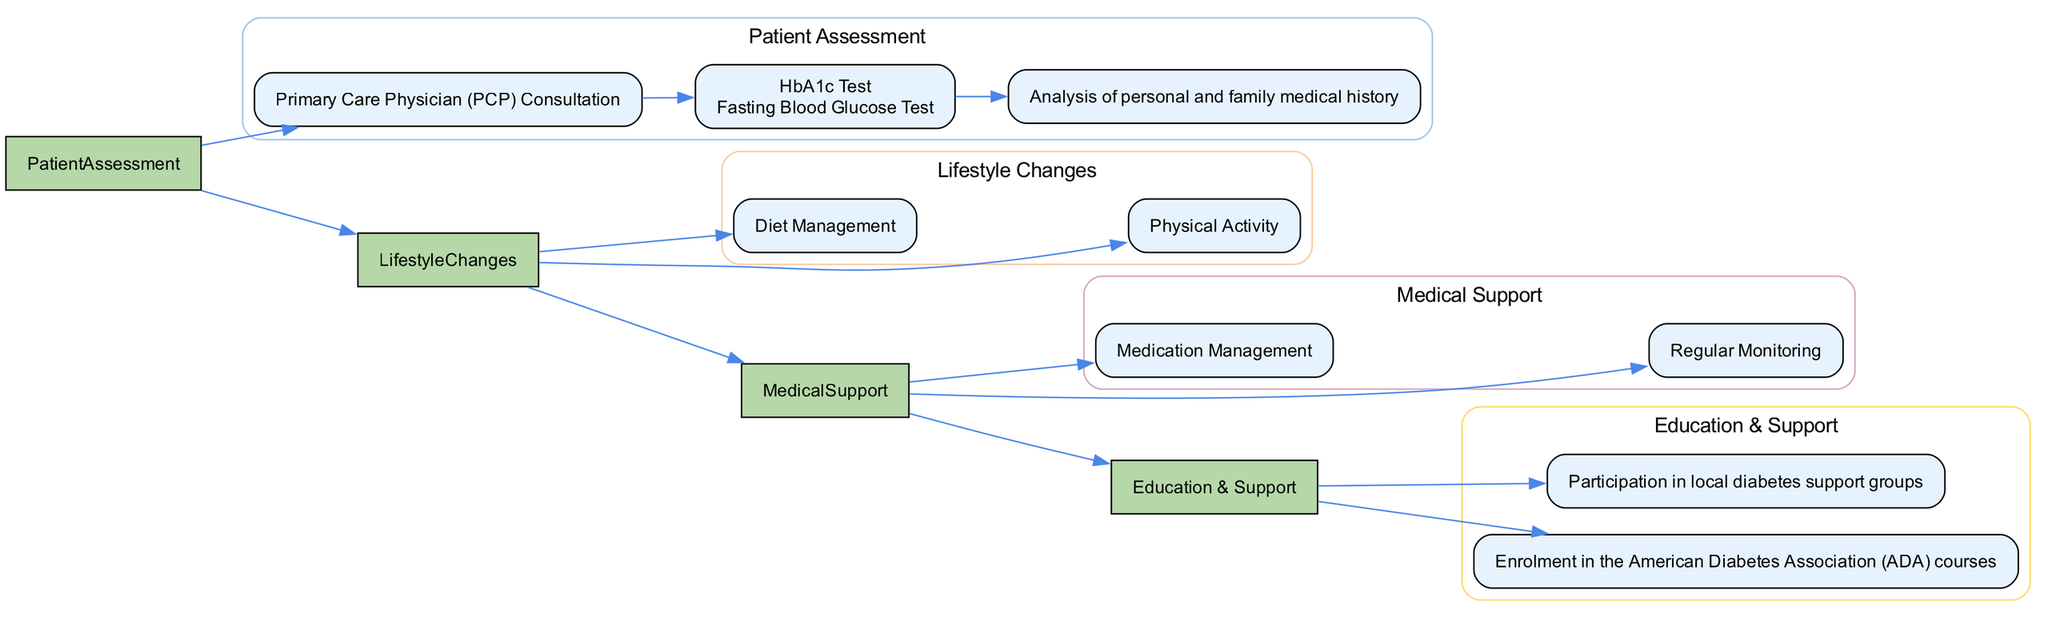What is the initial assessment node in the Patient Assessment stage? The diagram shows that the initial assessment for diabetes care begins with a Primary Care Physician (PCP) Consultation. This node directly identifies the starting point of the assessment process.
Answer: Primary Care Physician (PCP) Consultation How many diagnostic tests are listed in the Patient Assessment stage? The diagram specifies two diagnostic tests: the HbA1c Test and the Fasting Blood Glucose Test, which can be counted to answer this question.
Answer: 2 What are the two main components of Lifestyle Changes in diabetes management? The Lifestyle Changes section of the diagram indicates two main components: Diet Management and Physical Activity. These are the categories outlined by the visual layout.
Answer: Diet Management and Physical Activity What type of educational program is included in the Education and Support stage? According to the diagram, the educational program provided is the American Diabetes Association (ADA) courses, which is explicitly mentioned under the Education and Support section.
Answer: American Diabetes Association (ADA) courses How often should medication management be reviewed according to the diagram? The medication management is indicated to have a bi-monthly review frequency, which is stated directly in the Medical Support section of the pathway.
Answer: Bi-monthly Which component directly relates to tracking medication adherence? The diagram reveals that tracking and reminders are facilitated through the MySugr app, which is specified as a component of the Medication Management under Medical Support.
Answer: MySugr app How are physical activity levels monitored in the Lifestyle Changes stage? The diagram specifies that physical activity levels are monitored through monthly check-ups, outlining the frequency of these check-ins.
Answer: Monthly activity level check-ups What is the relationship between Patient Assessment and Lifestyle Changes in the diagram? The diagram illustrates a direct sequential connection from Patient Assessment to Lifestyle Changes, indicating that the assessment stage flows into implementing lifestyle changes next.
Answer: Direct connection What is one benefit of enrolling in peer support groups? While the diagram does not explicitly mention a benefit, participation in local diabetes support groups typically provides emotional and informational support for individuals managing diabetes. This can be inferred based on common knowledge related to peer support structures.
Answer: Emotional and informational support 